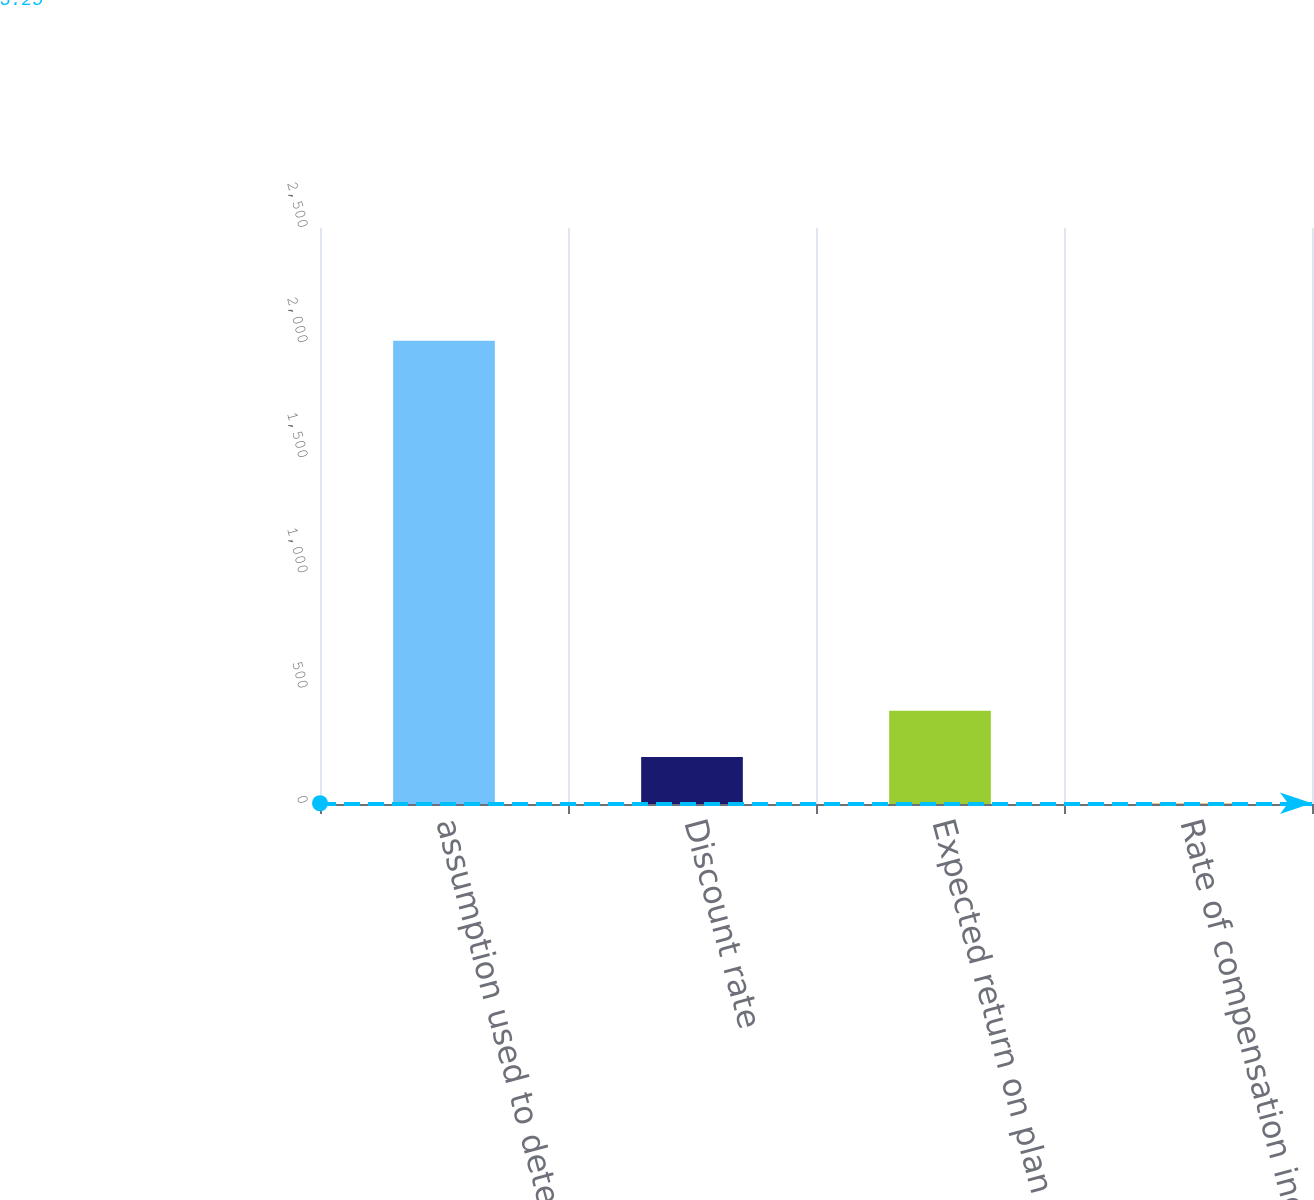Convert chart. <chart><loc_0><loc_0><loc_500><loc_500><bar_chart><fcel>assumption used to determine<fcel>Discount rate<fcel>Expected return on plan assets<fcel>Rate of compensation increase<nl><fcel>2011<fcel>204.03<fcel>404.81<fcel>3.25<nl></chart> 